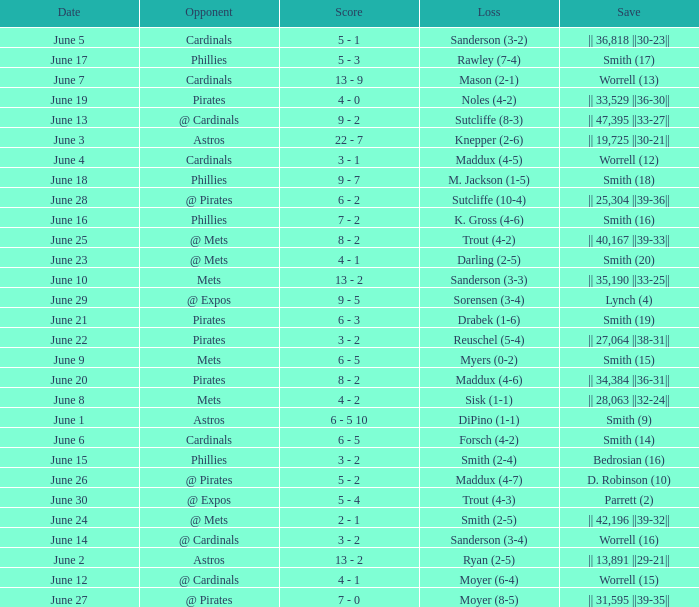What is the loss for the game against @ expos, with a save of parrett (2)? Trout (4-3). 